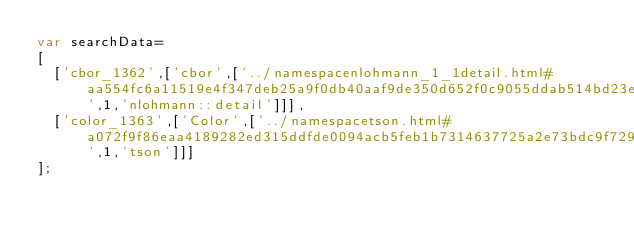<code> <loc_0><loc_0><loc_500><loc_500><_JavaScript_>var searchData=
[
  ['cbor_1362',['cbor',['../namespacenlohmann_1_1detail.html#aa554fc6a11519e4f347deb25a9f0db40aaf9de350d652f0c9055ddab514bd23ea',1,'nlohmann::detail']]],
  ['color_1363',['Color',['../namespacetson.html#a072f9f86eaa4189282ed315ddfde0094acb5feb1b7314637725a2e73bdc9f7295',1,'tson']]]
];
</code> 